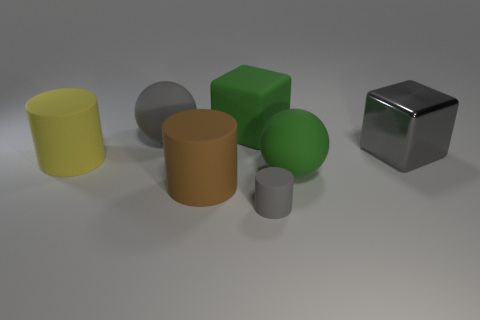Subtract 1 cylinders. How many cylinders are left? 2 Subtract all big cylinders. How many cylinders are left? 1 Subtract all spheres. How many objects are left? 5 Add 3 brown matte things. How many objects exist? 10 Subtract all big metal objects. Subtract all gray matte balls. How many objects are left? 5 Add 7 small matte cylinders. How many small matte cylinders are left? 8 Add 3 small objects. How many small objects exist? 4 Subtract 0 red cylinders. How many objects are left? 7 